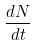<formula> <loc_0><loc_0><loc_500><loc_500>\frac { d N } { d t }</formula> 